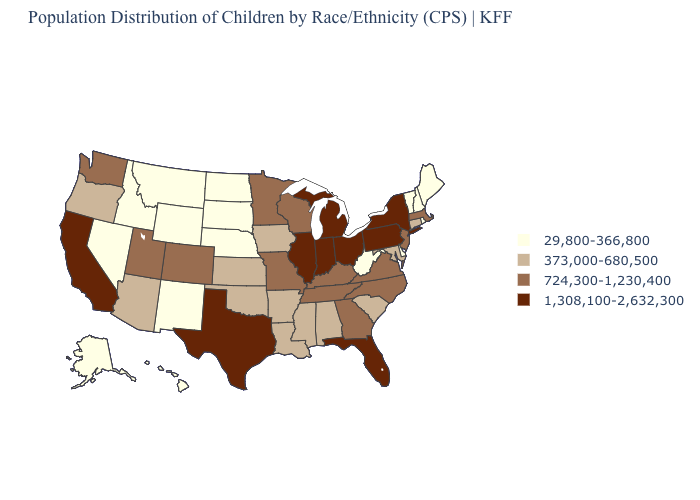Does Florida have a lower value than Colorado?
Keep it brief. No. What is the highest value in the USA?
Give a very brief answer. 1,308,100-2,632,300. What is the value of Illinois?
Answer briefly. 1,308,100-2,632,300. Does Illinois have the lowest value in the MidWest?
Keep it brief. No. Name the states that have a value in the range 373,000-680,500?
Answer briefly. Alabama, Arizona, Arkansas, Connecticut, Iowa, Kansas, Louisiana, Maryland, Mississippi, Oklahoma, Oregon, South Carolina. Does Pennsylvania have the same value as Ohio?
Quick response, please. Yes. Does Texas have a higher value than Michigan?
Be succinct. No. Which states have the lowest value in the USA?
Answer briefly. Alaska, Delaware, Hawaii, Idaho, Maine, Montana, Nebraska, Nevada, New Hampshire, New Mexico, North Dakota, Rhode Island, South Dakota, Vermont, West Virginia, Wyoming. Among the states that border New Hampshire , does Vermont have the highest value?
Keep it brief. No. Among the states that border Wisconsin , does Minnesota have the highest value?
Be succinct. No. Name the states that have a value in the range 1,308,100-2,632,300?
Quick response, please. California, Florida, Illinois, Indiana, Michigan, New York, Ohio, Pennsylvania, Texas. What is the lowest value in states that border Rhode Island?
Concise answer only. 373,000-680,500. Name the states that have a value in the range 373,000-680,500?
Concise answer only. Alabama, Arizona, Arkansas, Connecticut, Iowa, Kansas, Louisiana, Maryland, Mississippi, Oklahoma, Oregon, South Carolina. Which states hav the highest value in the MidWest?
Short answer required. Illinois, Indiana, Michigan, Ohio. 